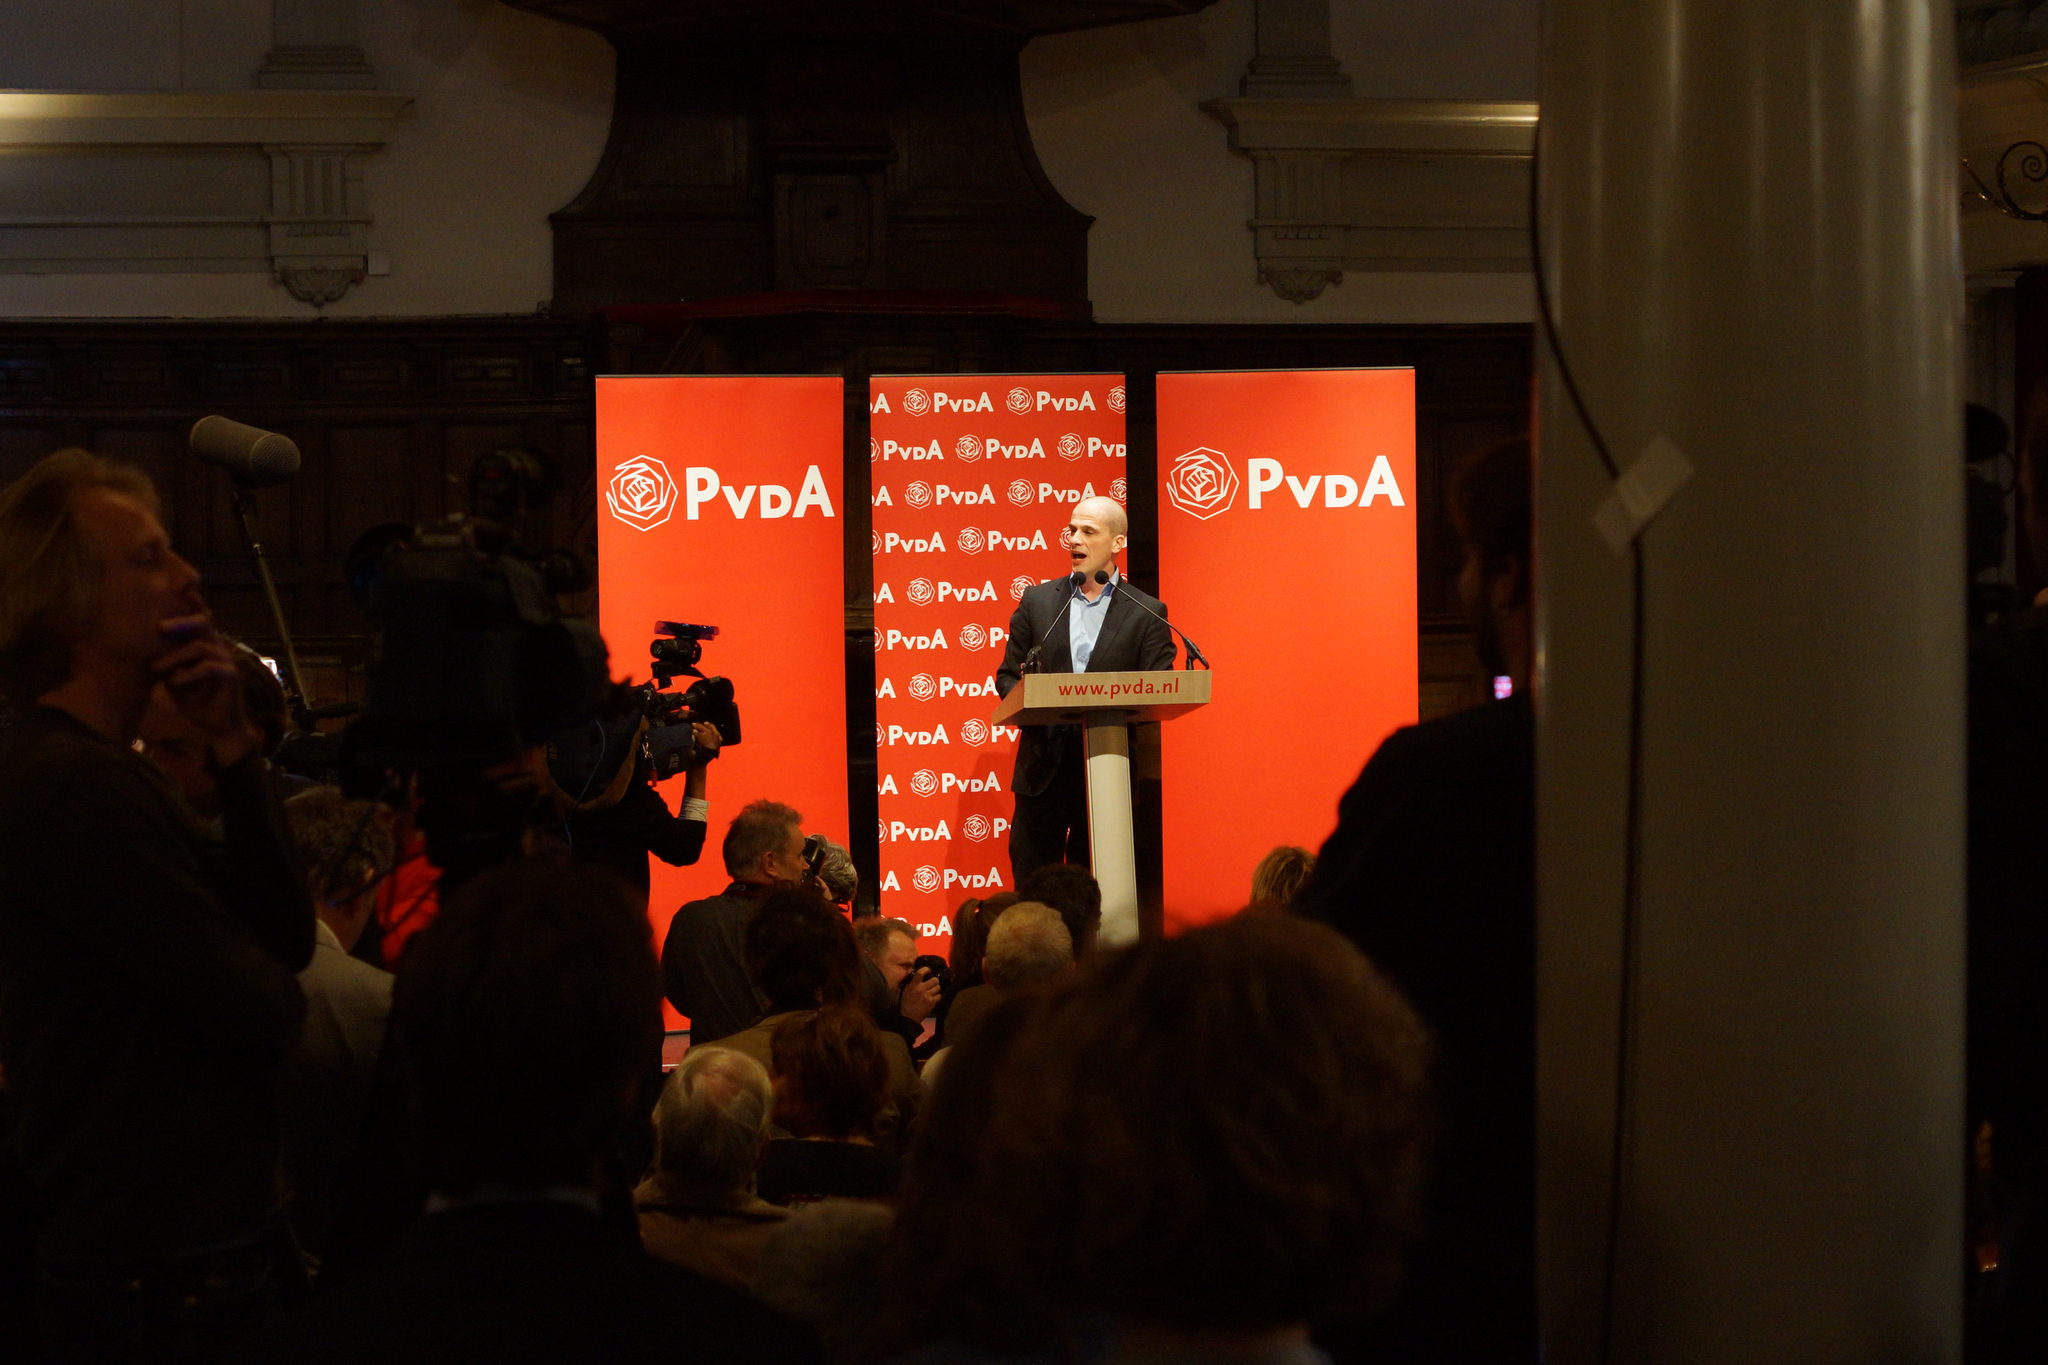How would you summarize this image in a sentence or two? In the image there is a man is standing in front of a table and talking something, behind him there is a logo and in the foreground there are many people holding cameras and on the right side there is a pillar. 